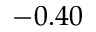Convert formula to latex. <formula><loc_0><loc_0><loc_500><loc_500>- 0 . 4 0</formula> 